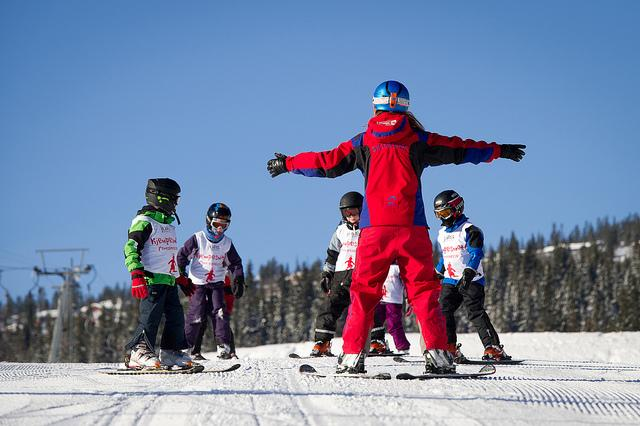What does the person in red provide? Please explain your reasoning. ski lessons. The other options don't match the setting. 